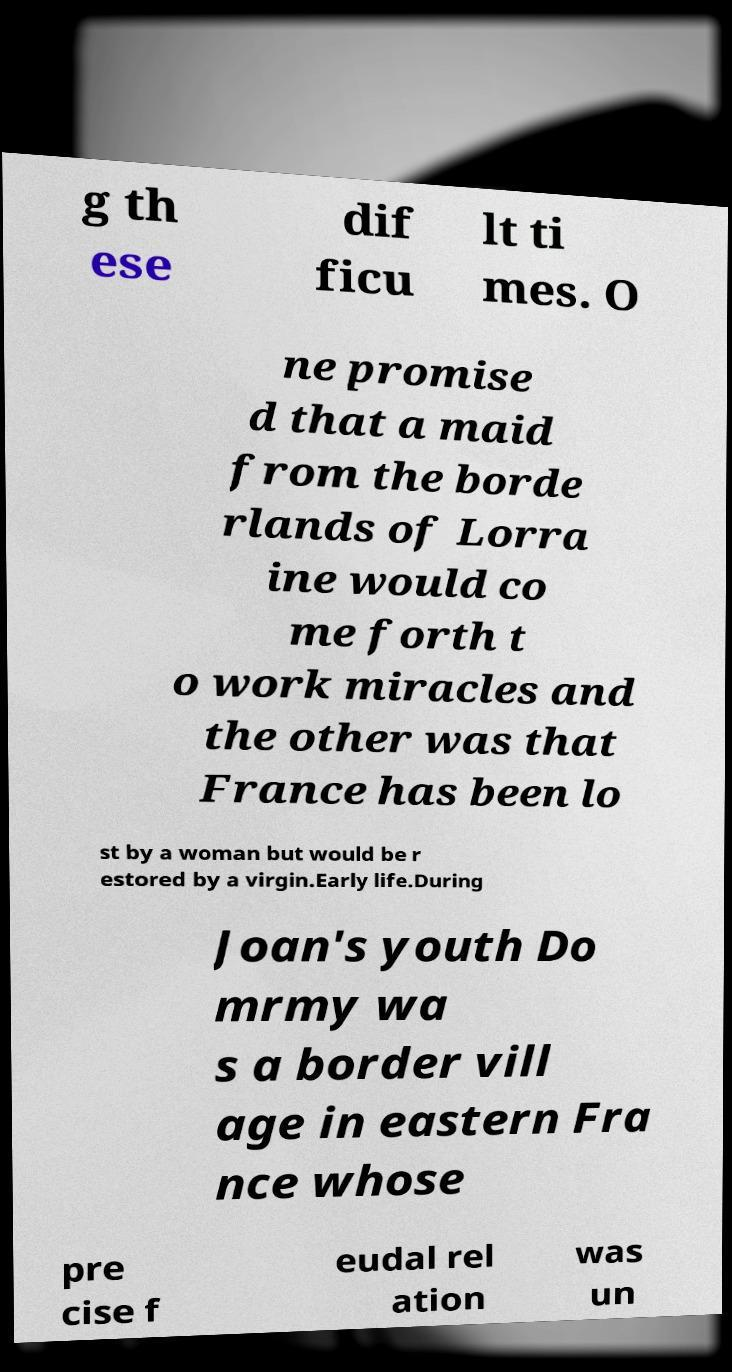What messages or text are displayed in this image? I need them in a readable, typed format. g th ese dif ficu lt ti mes. O ne promise d that a maid from the borde rlands of Lorra ine would co me forth t o work miracles and the other was that France has been lo st by a woman but would be r estored by a virgin.Early life.During Joan's youth Do mrmy wa s a border vill age in eastern Fra nce whose pre cise f eudal rel ation was un 